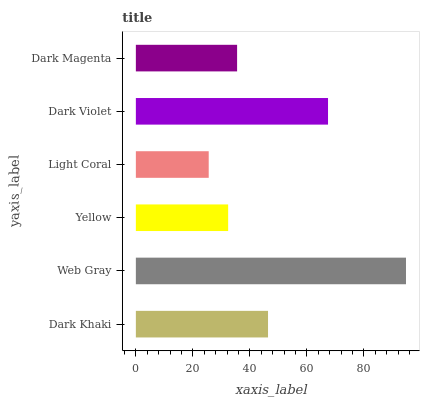Is Light Coral the minimum?
Answer yes or no. Yes. Is Web Gray the maximum?
Answer yes or no. Yes. Is Yellow the minimum?
Answer yes or no. No. Is Yellow the maximum?
Answer yes or no. No. Is Web Gray greater than Yellow?
Answer yes or no. Yes. Is Yellow less than Web Gray?
Answer yes or no. Yes. Is Yellow greater than Web Gray?
Answer yes or no. No. Is Web Gray less than Yellow?
Answer yes or no. No. Is Dark Khaki the high median?
Answer yes or no. Yes. Is Dark Magenta the low median?
Answer yes or no. Yes. Is Yellow the high median?
Answer yes or no. No. Is Yellow the low median?
Answer yes or no. No. 